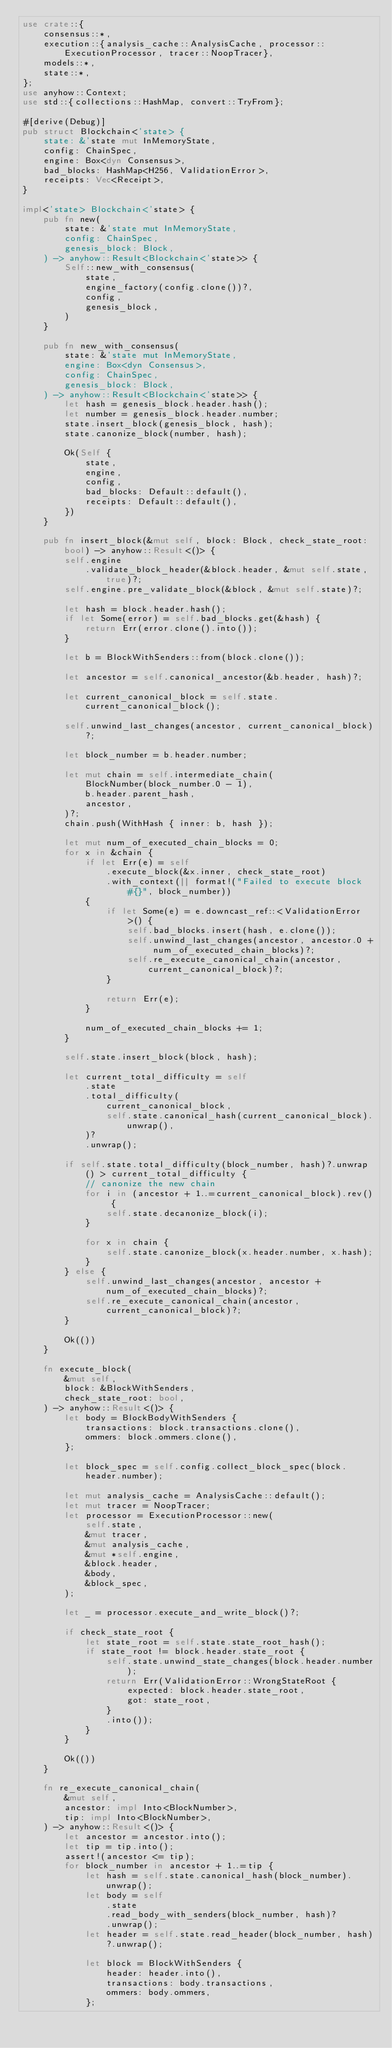Convert code to text. <code><loc_0><loc_0><loc_500><loc_500><_Rust_>use crate::{
    consensus::*,
    execution::{analysis_cache::AnalysisCache, processor::ExecutionProcessor, tracer::NoopTracer},
    models::*,
    state::*,
};
use anyhow::Context;
use std::{collections::HashMap, convert::TryFrom};

#[derive(Debug)]
pub struct Blockchain<'state> {
    state: &'state mut InMemoryState,
    config: ChainSpec,
    engine: Box<dyn Consensus>,
    bad_blocks: HashMap<H256, ValidationError>,
    receipts: Vec<Receipt>,
}

impl<'state> Blockchain<'state> {
    pub fn new(
        state: &'state mut InMemoryState,
        config: ChainSpec,
        genesis_block: Block,
    ) -> anyhow::Result<Blockchain<'state>> {
        Self::new_with_consensus(
            state,
            engine_factory(config.clone())?,
            config,
            genesis_block,
        )
    }

    pub fn new_with_consensus(
        state: &'state mut InMemoryState,
        engine: Box<dyn Consensus>,
        config: ChainSpec,
        genesis_block: Block,
    ) -> anyhow::Result<Blockchain<'state>> {
        let hash = genesis_block.header.hash();
        let number = genesis_block.header.number;
        state.insert_block(genesis_block, hash);
        state.canonize_block(number, hash);

        Ok(Self {
            state,
            engine,
            config,
            bad_blocks: Default::default(),
            receipts: Default::default(),
        })
    }

    pub fn insert_block(&mut self, block: Block, check_state_root: bool) -> anyhow::Result<()> {
        self.engine
            .validate_block_header(&block.header, &mut self.state, true)?;
        self.engine.pre_validate_block(&block, &mut self.state)?;

        let hash = block.header.hash();
        if let Some(error) = self.bad_blocks.get(&hash) {
            return Err(error.clone().into());
        }

        let b = BlockWithSenders::from(block.clone());

        let ancestor = self.canonical_ancestor(&b.header, hash)?;

        let current_canonical_block = self.state.current_canonical_block();

        self.unwind_last_changes(ancestor, current_canonical_block)?;

        let block_number = b.header.number;

        let mut chain = self.intermediate_chain(
            BlockNumber(block_number.0 - 1),
            b.header.parent_hash,
            ancestor,
        )?;
        chain.push(WithHash { inner: b, hash });

        let mut num_of_executed_chain_blocks = 0;
        for x in &chain {
            if let Err(e) = self
                .execute_block(&x.inner, check_state_root)
                .with_context(|| format!("Failed to execute block #{}", block_number))
            {
                if let Some(e) = e.downcast_ref::<ValidationError>() {
                    self.bad_blocks.insert(hash, e.clone());
                    self.unwind_last_changes(ancestor, ancestor.0 + num_of_executed_chain_blocks)?;
                    self.re_execute_canonical_chain(ancestor, current_canonical_block)?;
                }

                return Err(e);
            }

            num_of_executed_chain_blocks += 1;
        }

        self.state.insert_block(block, hash);

        let current_total_difficulty = self
            .state
            .total_difficulty(
                current_canonical_block,
                self.state.canonical_hash(current_canonical_block).unwrap(),
            )?
            .unwrap();

        if self.state.total_difficulty(block_number, hash)?.unwrap() > current_total_difficulty {
            // canonize the new chain
            for i in (ancestor + 1..=current_canonical_block).rev() {
                self.state.decanonize_block(i);
            }

            for x in chain {
                self.state.canonize_block(x.header.number, x.hash);
            }
        } else {
            self.unwind_last_changes(ancestor, ancestor + num_of_executed_chain_blocks)?;
            self.re_execute_canonical_chain(ancestor, current_canonical_block)?;
        }

        Ok(())
    }

    fn execute_block(
        &mut self,
        block: &BlockWithSenders,
        check_state_root: bool,
    ) -> anyhow::Result<()> {
        let body = BlockBodyWithSenders {
            transactions: block.transactions.clone(),
            ommers: block.ommers.clone(),
        };

        let block_spec = self.config.collect_block_spec(block.header.number);

        let mut analysis_cache = AnalysisCache::default();
        let mut tracer = NoopTracer;
        let processor = ExecutionProcessor::new(
            self.state,
            &mut tracer,
            &mut analysis_cache,
            &mut *self.engine,
            &block.header,
            &body,
            &block_spec,
        );

        let _ = processor.execute_and_write_block()?;

        if check_state_root {
            let state_root = self.state.state_root_hash();
            if state_root != block.header.state_root {
                self.state.unwind_state_changes(block.header.number);
                return Err(ValidationError::WrongStateRoot {
                    expected: block.header.state_root,
                    got: state_root,
                }
                .into());
            }
        }

        Ok(())
    }

    fn re_execute_canonical_chain(
        &mut self,
        ancestor: impl Into<BlockNumber>,
        tip: impl Into<BlockNumber>,
    ) -> anyhow::Result<()> {
        let ancestor = ancestor.into();
        let tip = tip.into();
        assert!(ancestor <= tip);
        for block_number in ancestor + 1..=tip {
            let hash = self.state.canonical_hash(block_number).unwrap();
            let body = self
                .state
                .read_body_with_senders(block_number, hash)?
                .unwrap();
            let header = self.state.read_header(block_number, hash)?.unwrap();

            let block = BlockWithSenders {
                header: header.into(),
                transactions: body.transactions,
                ommers: body.ommers,
            };
</code> 